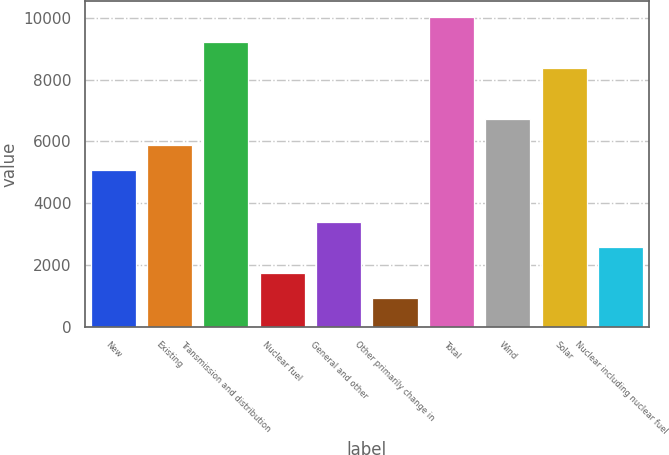Convert chart. <chart><loc_0><loc_0><loc_500><loc_500><bar_chart><fcel>New<fcel>Existing<fcel>Transmission and distribution<fcel>Nuclear fuel<fcel>General and other<fcel>Other primarily change in<fcel>Total<fcel>Wind<fcel>Solar<fcel>Nuclear including nuclear fuel<nl><fcel>5059.4<fcel>5888.8<fcel>9206.4<fcel>1741.8<fcel>3400.6<fcel>912.4<fcel>10035.8<fcel>6718.2<fcel>8377<fcel>2571.2<nl></chart> 